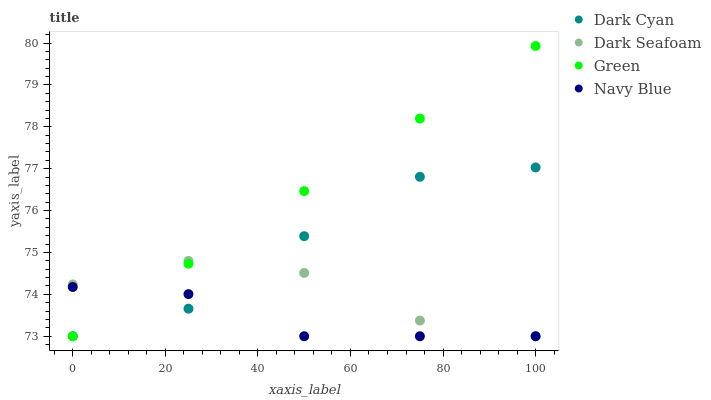Does Navy Blue have the minimum area under the curve?
Answer yes or no. Yes. Does Green have the maximum area under the curve?
Answer yes or no. Yes. Does Dark Seafoam have the minimum area under the curve?
Answer yes or no. No. Does Dark Seafoam have the maximum area under the curve?
Answer yes or no. No. Is Green the smoothest?
Answer yes or no. Yes. Is Dark Cyan the roughest?
Answer yes or no. Yes. Is Navy Blue the smoothest?
Answer yes or no. No. Is Navy Blue the roughest?
Answer yes or no. No. Does Dark Cyan have the lowest value?
Answer yes or no. Yes. Does Green have the highest value?
Answer yes or no. Yes. Does Dark Seafoam have the highest value?
Answer yes or no. No. Does Green intersect Navy Blue?
Answer yes or no. Yes. Is Green less than Navy Blue?
Answer yes or no. No. Is Green greater than Navy Blue?
Answer yes or no. No. 